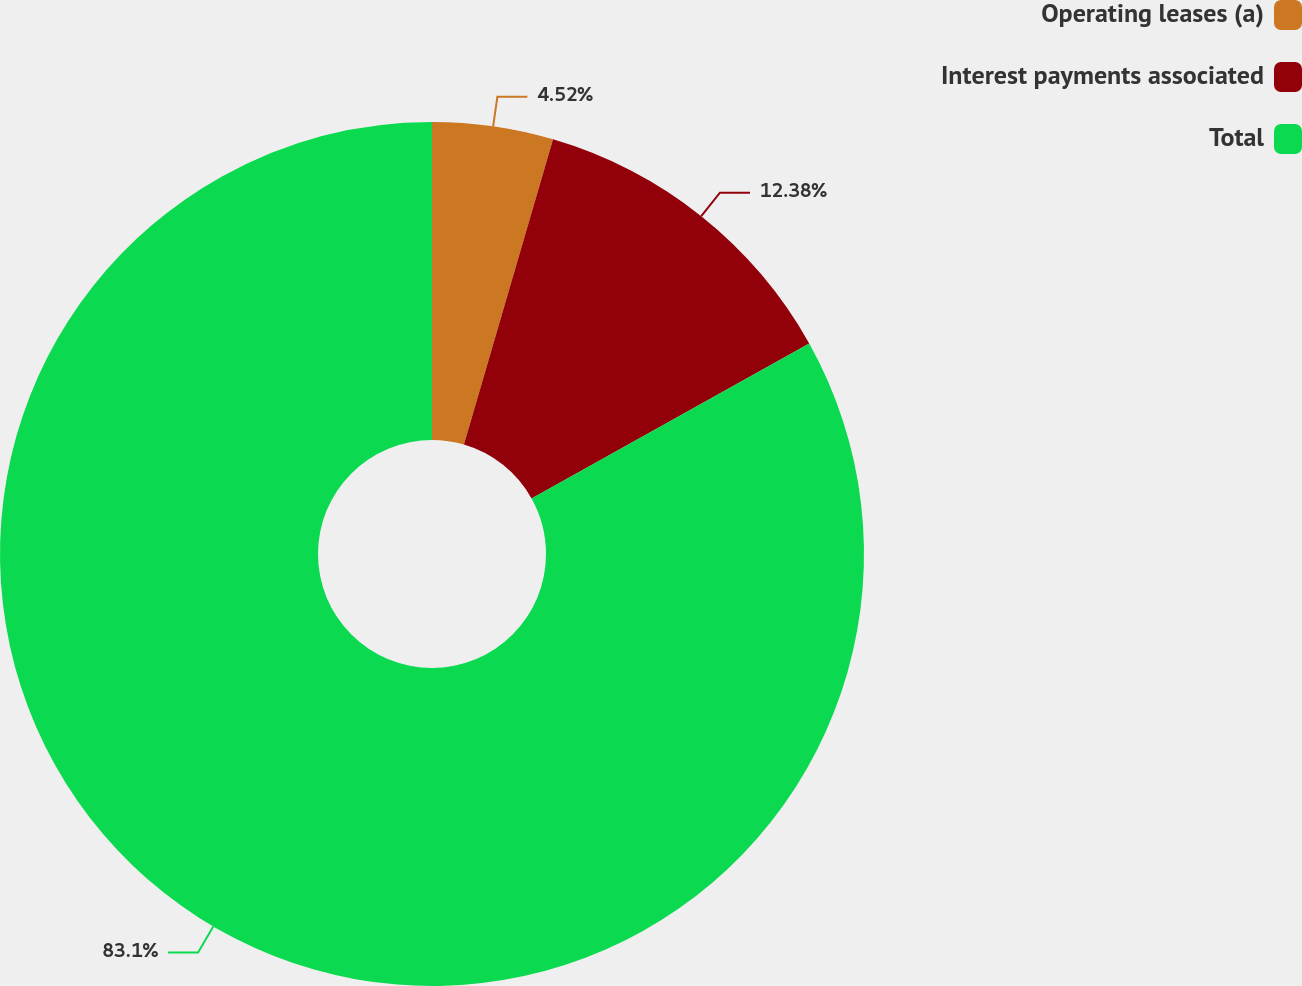Convert chart to OTSL. <chart><loc_0><loc_0><loc_500><loc_500><pie_chart><fcel>Operating leases (a)<fcel>Interest payments associated<fcel>Total<nl><fcel>4.52%<fcel>12.38%<fcel>83.1%<nl></chart> 